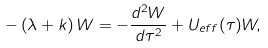<formula> <loc_0><loc_0><loc_500><loc_500>- \left ( \lambda + k \right ) W = - \frac { d ^ { 2 } W } { d \tau ^ { 2 } } + U _ { e f f } ( \tau ) W ,</formula> 